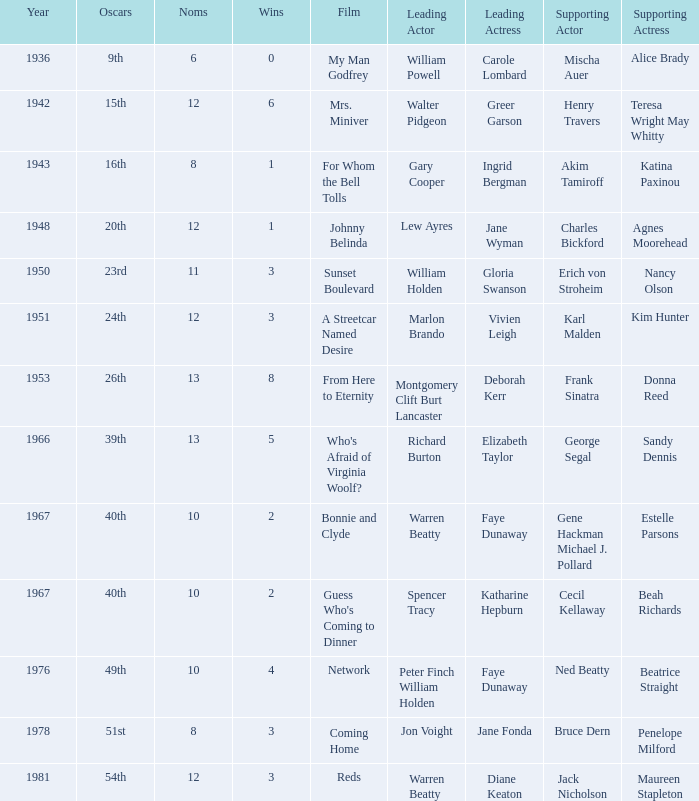Who was the supporting actress in a film with Diane Keaton as the leading actress? Maureen Stapleton. 